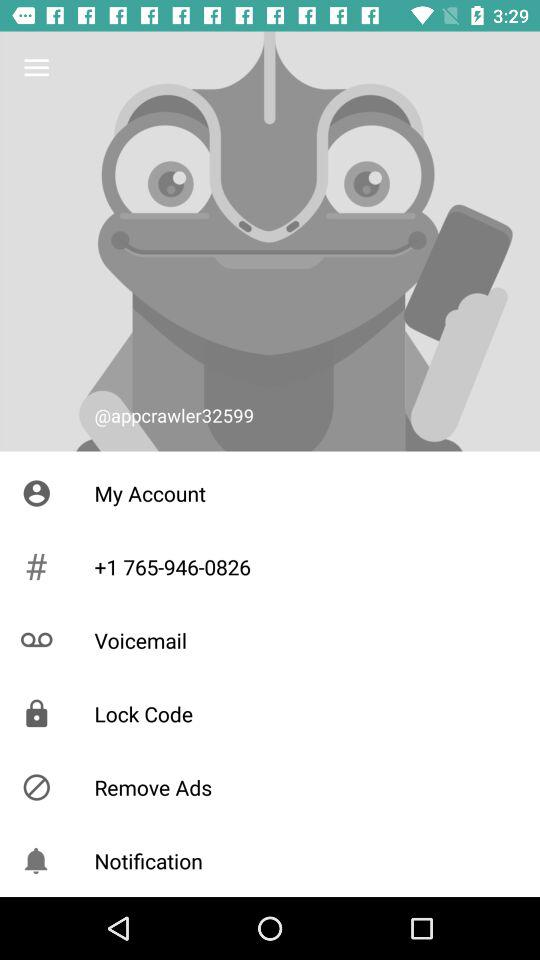What is the username? The username is "@appcrawler32599". 